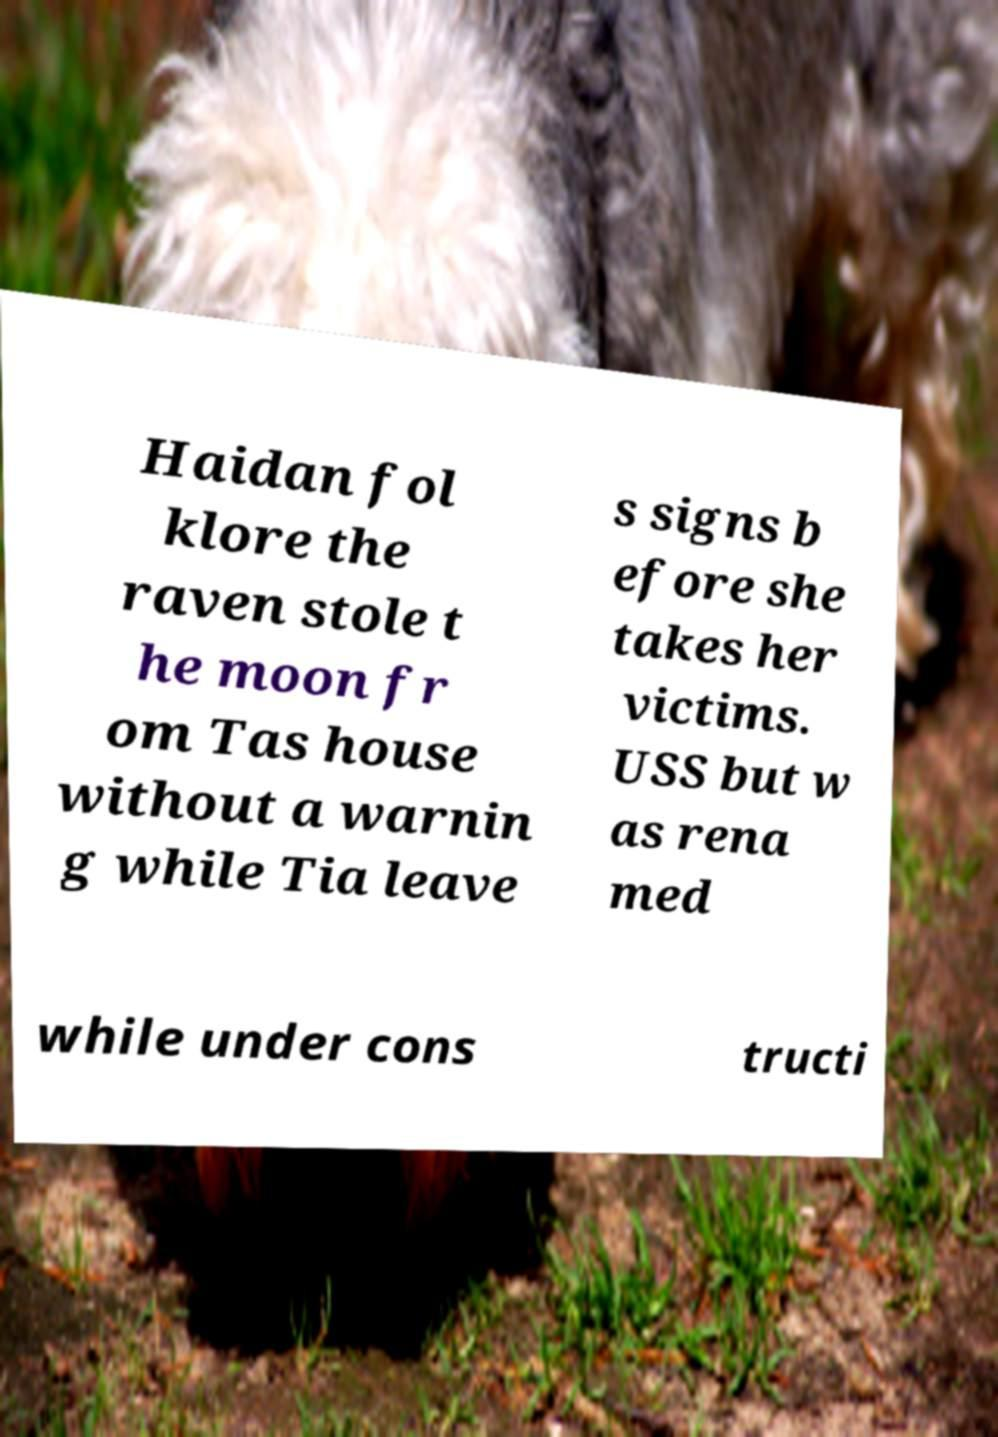For documentation purposes, I need the text within this image transcribed. Could you provide that? Haidan fol klore the raven stole t he moon fr om Tas house without a warnin g while Tia leave s signs b efore she takes her victims. USS but w as rena med while under cons tructi 